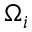<formula> <loc_0><loc_0><loc_500><loc_500>\Omega _ { i }</formula> 